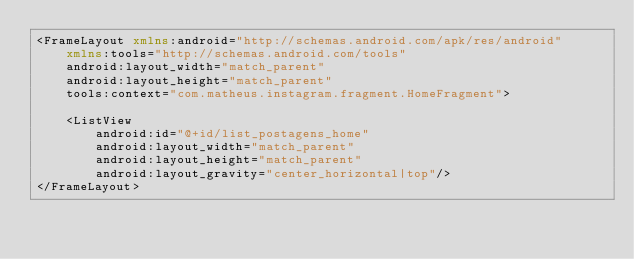<code> <loc_0><loc_0><loc_500><loc_500><_XML_><FrameLayout xmlns:android="http://schemas.android.com/apk/res/android"
    xmlns:tools="http://schemas.android.com/tools"
    android:layout_width="match_parent"
    android:layout_height="match_parent"
    tools:context="com.matheus.instagram.fragment.HomeFragment">

    <ListView
        android:id="@+id/list_postagens_home"
        android:layout_width="match_parent"
        android:layout_height="match_parent"
        android:layout_gravity="center_horizontal|top"/>
</FrameLayout>
</code> 